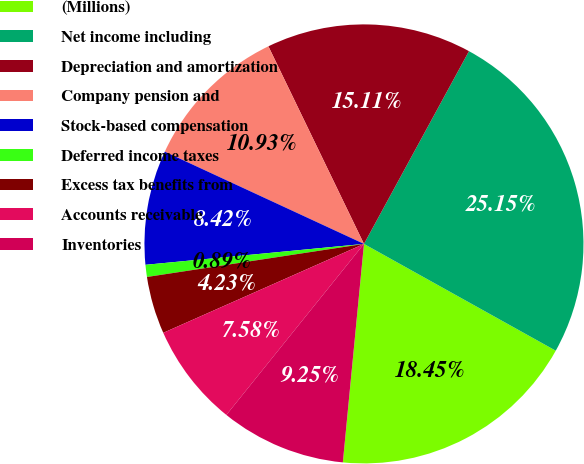<chart> <loc_0><loc_0><loc_500><loc_500><pie_chart><fcel>(Millions)<fcel>Net income including<fcel>Depreciation and amortization<fcel>Company pension and<fcel>Stock-based compensation<fcel>Deferred income taxes<fcel>Excess tax benefits from<fcel>Accounts receivable<fcel>Inventories<nl><fcel>18.45%<fcel>25.15%<fcel>15.11%<fcel>10.93%<fcel>8.42%<fcel>0.89%<fcel>4.23%<fcel>7.58%<fcel>9.25%<nl></chart> 